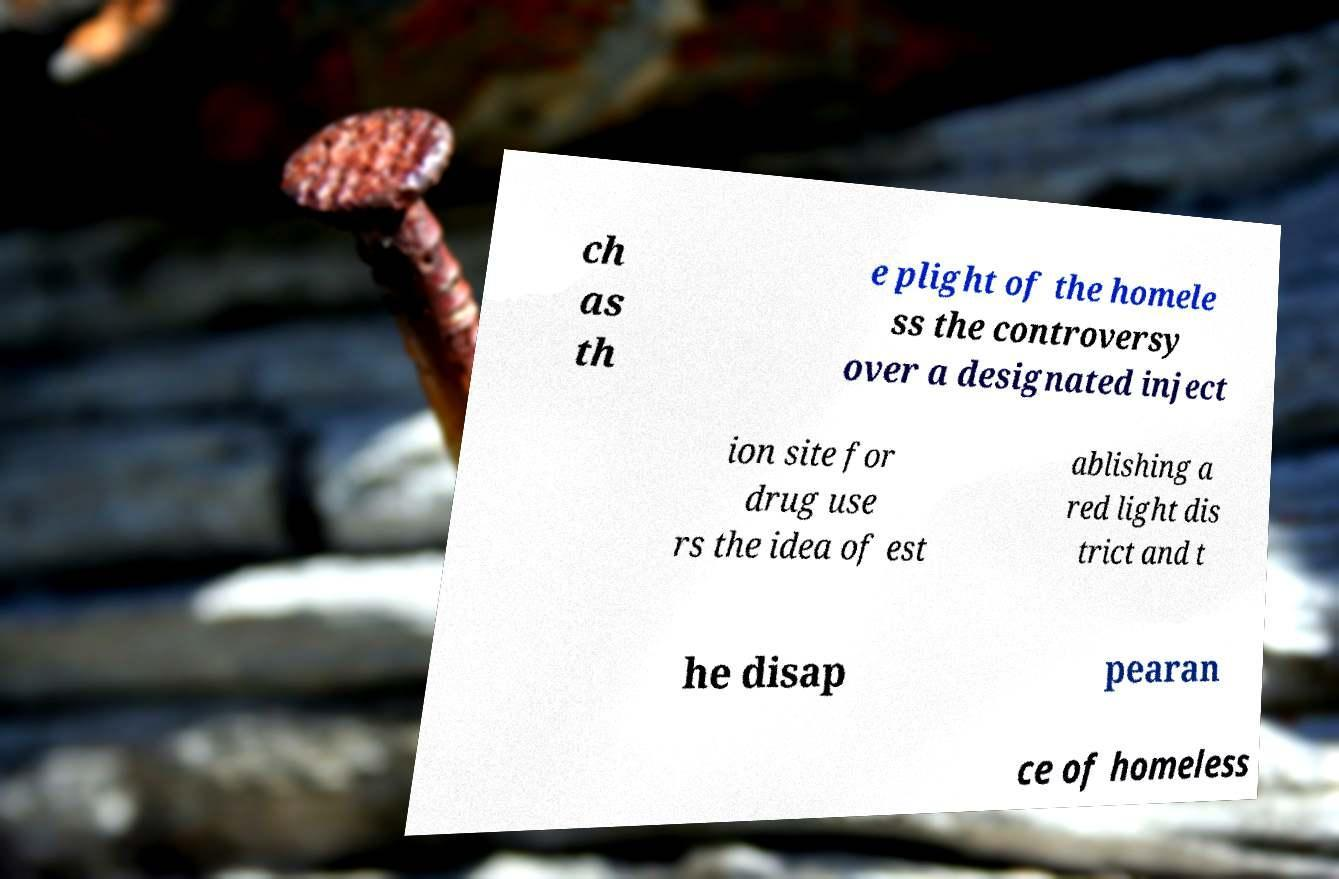I need the written content from this picture converted into text. Can you do that? ch as th e plight of the homele ss the controversy over a designated inject ion site for drug use rs the idea of est ablishing a red light dis trict and t he disap pearan ce of homeless 